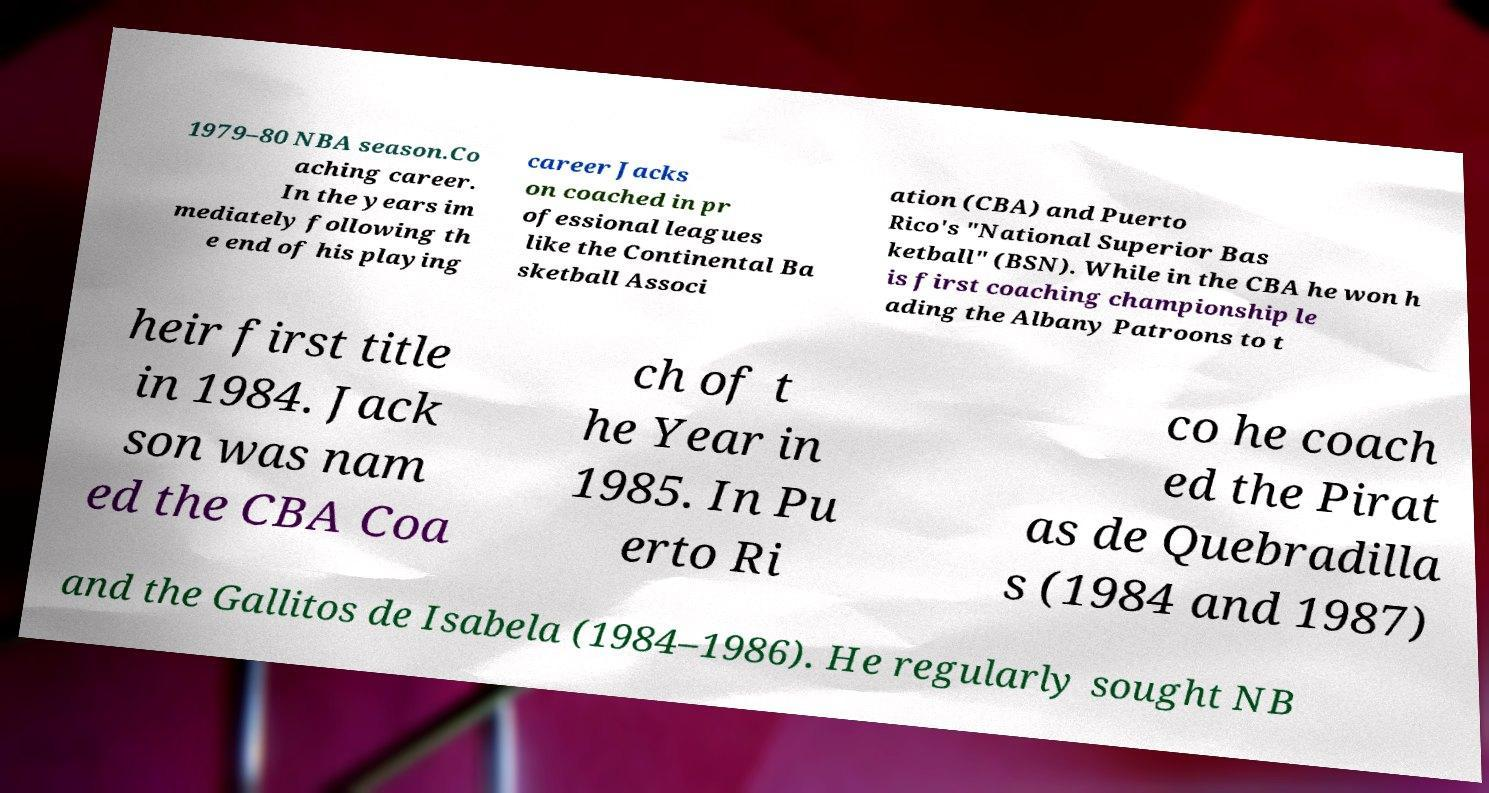Could you extract and type out the text from this image? 1979–80 NBA season.Co aching career. In the years im mediately following th e end of his playing career Jacks on coached in pr ofessional leagues like the Continental Ba sketball Associ ation (CBA) and Puerto Rico's "National Superior Bas ketball" (BSN). While in the CBA he won h is first coaching championship le ading the Albany Patroons to t heir first title in 1984. Jack son was nam ed the CBA Coa ch of t he Year in 1985. In Pu erto Ri co he coach ed the Pirat as de Quebradilla s (1984 and 1987) and the Gallitos de Isabela (1984–1986). He regularly sought NB 